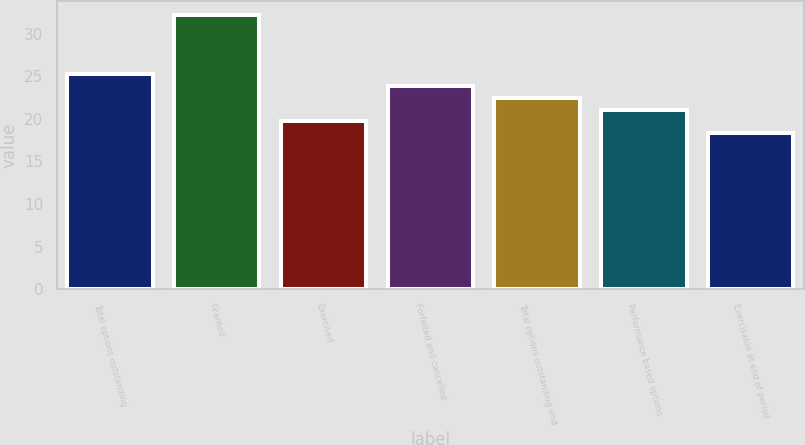<chart> <loc_0><loc_0><loc_500><loc_500><bar_chart><fcel>Total options outstanding<fcel>Granted<fcel>Exercised<fcel>Forfeited and cancelled<fcel>Total options outstanding end<fcel>Performance based options<fcel>Exercisable at end of period<nl><fcel>25.26<fcel>32.25<fcel>19.7<fcel>23.87<fcel>22.48<fcel>21.09<fcel>18.31<nl></chart> 